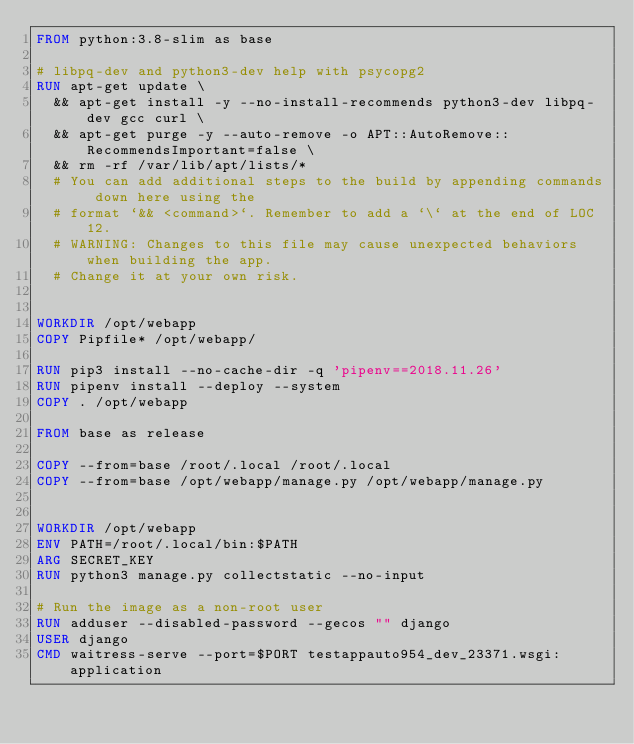Convert code to text. <code><loc_0><loc_0><loc_500><loc_500><_Dockerfile_>FROM python:3.8-slim as base

# libpq-dev and python3-dev help with psycopg2
RUN apt-get update \
  && apt-get install -y --no-install-recommends python3-dev libpq-dev gcc curl \
  && apt-get purge -y --auto-remove -o APT::AutoRemove::RecommendsImportant=false \
  && rm -rf /var/lib/apt/lists/*
  # You can add additional steps to the build by appending commands down here using the
  # format `&& <command>`. Remember to add a `\` at the end of LOC 12.
  # WARNING: Changes to this file may cause unexpected behaviors when building the app.
  # Change it at your own risk.


WORKDIR /opt/webapp
COPY Pipfile* /opt/webapp/

RUN pip3 install --no-cache-dir -q 'pipenv==2018.11.26' 
RUN pipenv install --deploy --system
COPY . /opt/webapp

FROM base as release

COPY --from=base /root/.local /root/.local
COPY --from=base /opt/webapp/manage.py /opt/webapp/manage.py


WORKDIR /opt/webapp
ENV PATH=/root/.local/bin:$PATH
ARG SECRET_KEY 
RUN python3 manage.py collectstatic --no-input

# Run the image as a non-root user
RUN adduser --disabled-password --gecos "" django
USER django
CMD waitress-serve --port=$PORT testappauto954_dev_23371.wsgi:application
</code> 